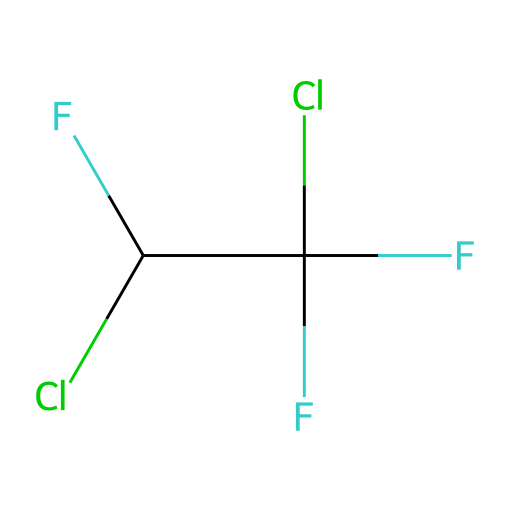What is the name of this refrigerant? The provided SMILES notation corresponds to the refrigerant known as R-22, which is commonly referred to as dichlorodifluoromethane.
Answer: R-22 How many chlorine atoms are present in the structure? On examining the SMILES notation, "Cl" appears twice, indicating there are two chlorine atoms in the molecular structure.
Answer: two What type of chemical bonds are present between the atoms? The structure consists primarily of single covalent bonds between the carbon and halogen atoms, as indicated by the absence of double or triple bonds in the SMILES notation.
Answer: single covalent bonds What is the total number of fluorine atoms in the molecule? In the SMILES representation, "F" appears three times, suggesting that the molecule has three fluorine atoms in its structure.
Answer: three What is the carbon atom's hybridization in R-22? The carbon atom in R-22 is bonded to three other atoms (two fluorines and one chlorine) in a tetrahedral arrangement, indicating that it is sp3 hybridized.
Answer: sp3 Why is R-22 being phased out? R-22 is being phased out primarily due to its high ozone depletion potential and contribution to climate change as a potent greenhouse gas, leading to environmental concerns.
Answer: ozone depletion Is R-22 a pure substance or a mixture? R-22 is categorized as a pure substance because it has a well-defined chemical composition and specific properties that characterize it as a distinct chemical entity.
Answer: pure substance 